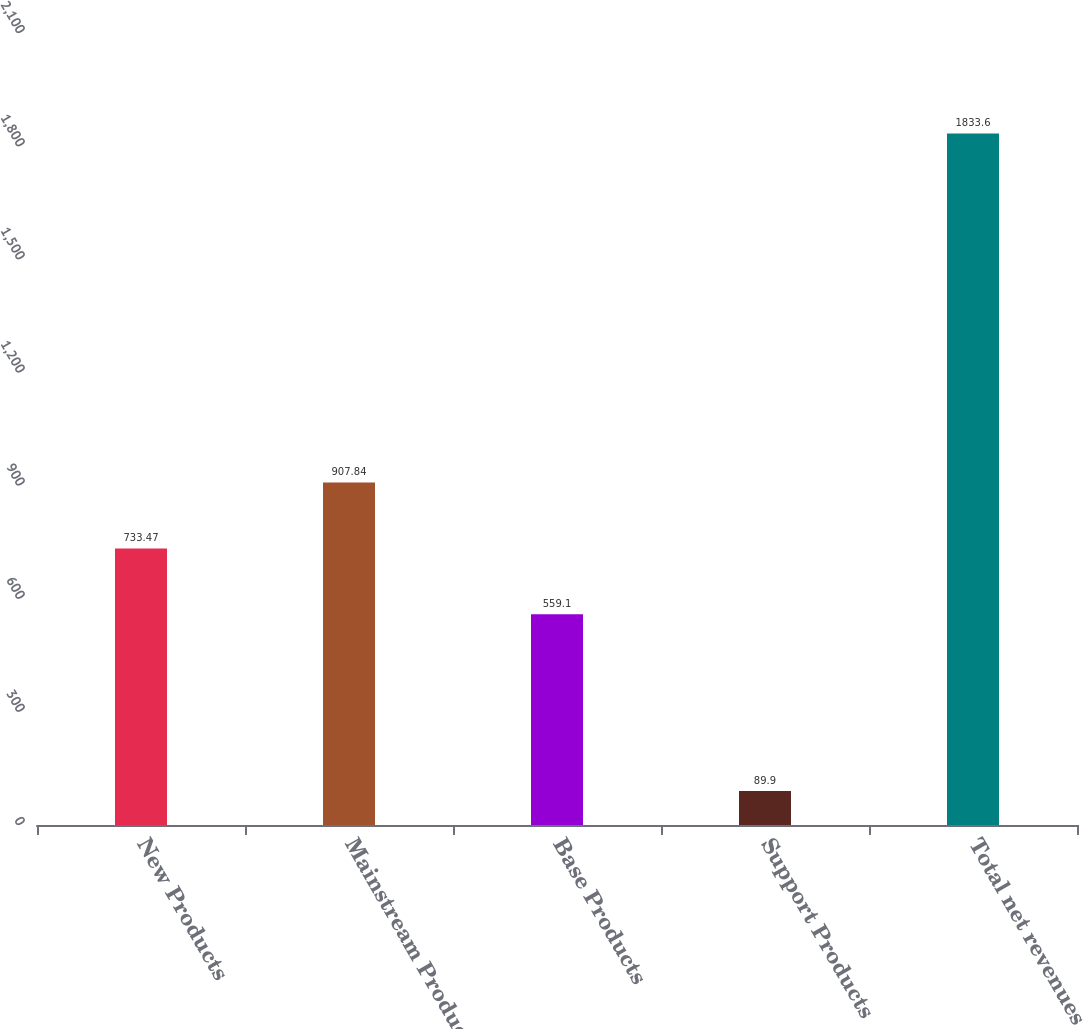Convert chart. <chart><loc_0><loc_0><loc_500><loc_500><bar_chart><fcel>New Products<fcel>Mainstream Products<fcel>Base Products<fcel>Support Products<fcel>Total net revenues<nl><fcel>733.47<fcel>907.84<fcel>559.1<fcel>89.9<fcel>1833.6<nl></chart> 